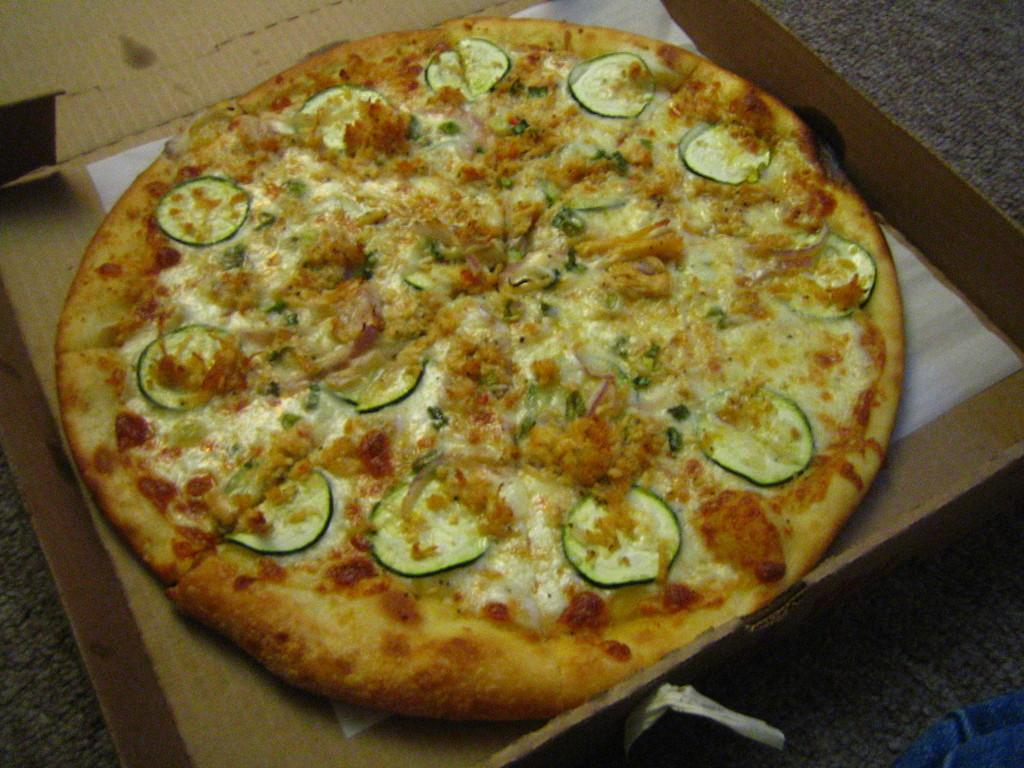What type of food is visible in the image? There is a pizza in the image. What type of container is present in the image? There is a carton box in the image. What type of writing material is visible in the image? There is a paper in the image. What type of cork can be seen in the image? There is no cork present in the image. How many oranges are visible in the image? There are no oranges visible in the image. 